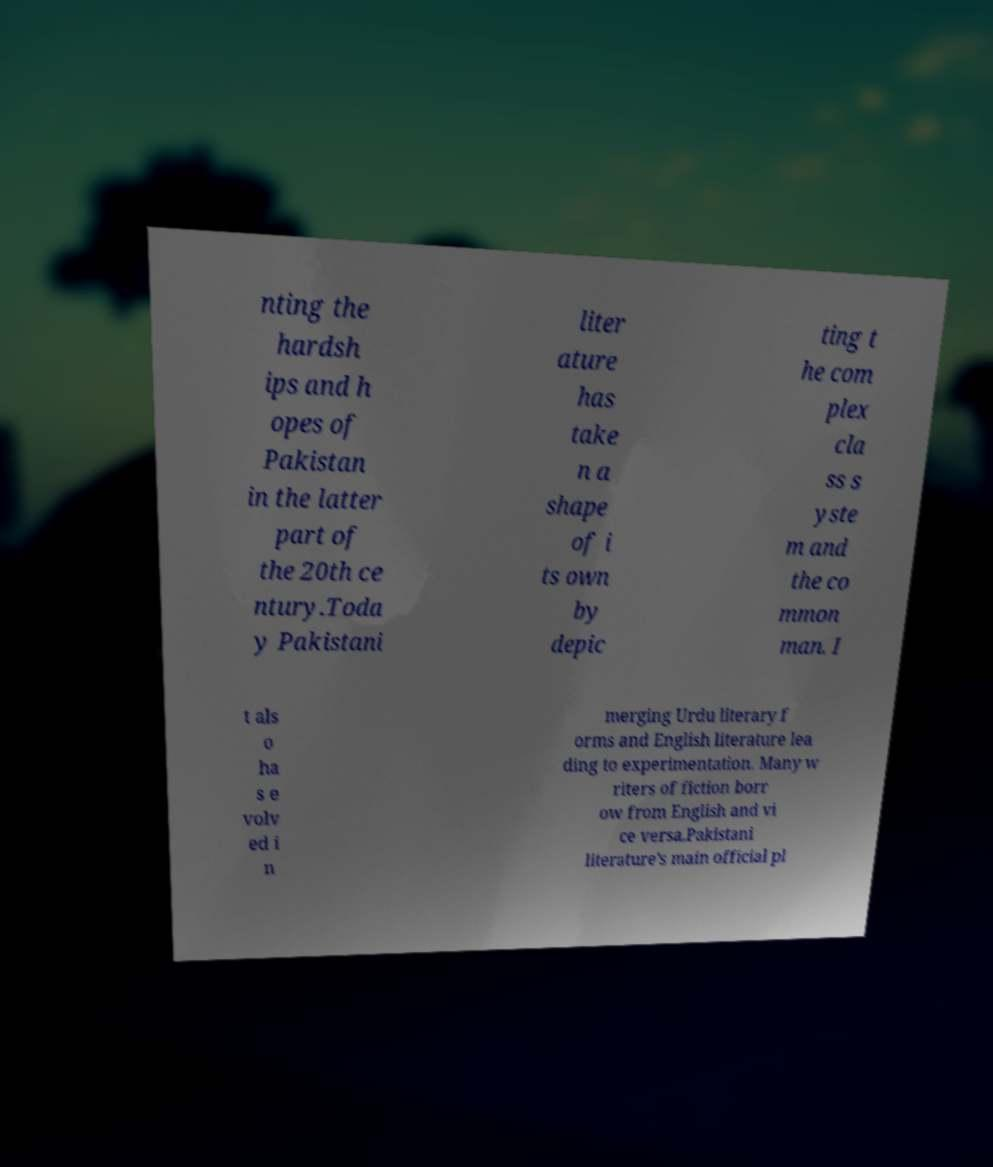Could you extract and type out the text from this image? nting the hardsh ips and h opes of Pakistan in the latter part of the 20th ce ntury.Toda y Pakistani liter ature has take n a shape of i ts own by depic ting t he com plex cla ss s yste m and the co mmon man. I t als o ha s e volv ed i n merging Urdu literary f orms and English literature lea ding to experimentation. Many w riters of fiction borr ow from English and vi ce versa.Pakistani literature's main official pl 